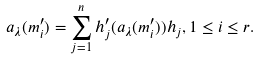<formula> <loc_0><loc_0><loc_500><loc_500>a _ { \lambda } ( m ^ { \prime } _ { i } ) = \sum ^ { n } _ { j = 1 } h ^ { \prime } _ { j } ( a _ { \lambda } ( m ^ { \prime } _ { i } ) ) h _ { j } , 1 \leq i \leq r .</formula> 